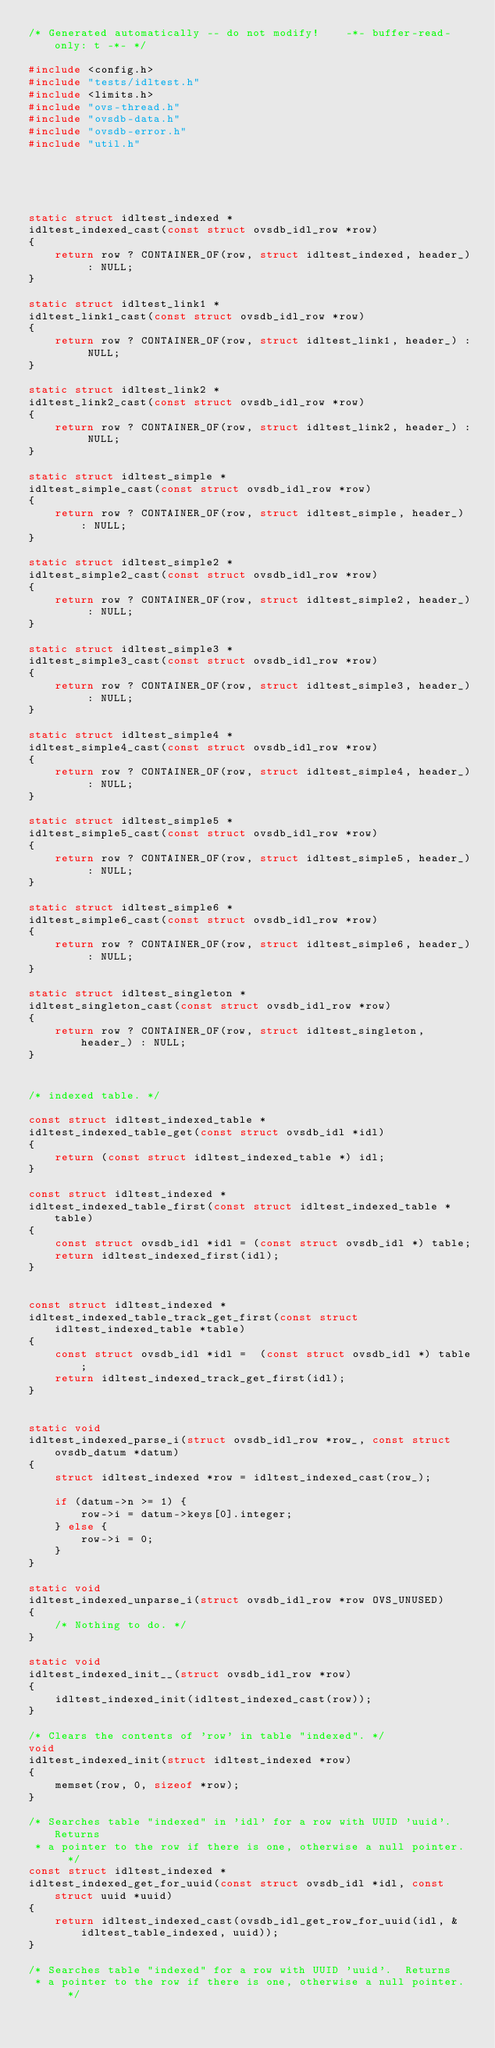<code> <loc_0><loc_0><loc_500><loc_500><_C_>/* Generated automatically -- do not modify!    -*- buffer-read-only: t -*- */

#include <config.h>
#include "tests/idltest.h"
#include <limits.h>
#include "ovs-thread.h"
#include "ovsdb-data.h"
#include "ovsdb-error.h"
#include "util.h"





static struct idltest_indexed *
idltest_indexed_cast(const struct ovsdb_idl_row *row)
{
    return row ? CONTAINER_OF(row, struct idltest_indexed, header_) : NULL;
}

static struct idltest_link1 *
idltest_link1_cast(const struct ovsdb_idl_row *row)
{
    return row ? CONTAINER_OF(row, struct idltest_link1, header_) : NULL;
}

static struct idltest_link2 *
idltest_link2_cast(const struct ovsdb_idl_row *row)
{
    return row ? CONTAINER_OF(row, struct idltest_link2, header_) : NULL;
}

static struct idltest_simple *
idltest_simple_cast(const struct ovsdb_idl_row *row)
{
    return row ? CONTAINER_OF(row, struct idltest_simple, header_) : NULL;
}

static struct idltest_simple2 *
idltest_simple2_cast(const struct ovsdb_idl_row *row)
{
    return row ? CONTAINER_OF(row, struct idltest_simple2, header_) : NULL;
}

static struct idltest_simple3 *
idltest_simple3_cast(const struct ovsdb_idl_row *row)
{
    return row ? CONTAINER_OF(row, struct idltest_simple3, header_) : NULL;
}

static struct idltest_simple4 *
idltest_simple4_cast(const struct ovsdb_idl_row *row)
{
    return row ? CONTAINER_OF(row, struct idltest_simple4, header_) : NULL;
}

static struct idltest_simple5 *
idltest_simple5_cast(const struct ovsdb_idl_row *row)
{
    return row ? CONTAINER_OF(row, struct idltest_simple5, header_) : NULL;
}

static struct idltest_simple6 *
idltest_simple6_cast(const struct ovsdb_idl_row *row)
{
    return row ? CONTAINER_OF(row, struct idltest_simple6, header_) : NULL;
}

static struct idltest_singleton *
idltest_singleton_cast(const struct ovsdb_idl_row *row)
{
    return row ? CONTAINER_OF(row, struct idltest_singleton, header_) : NULL;
}

/* indexed table. */

const struct idltest_indexed_table *
idltest_indexed_table_get(const struct ovsdb_idl *idl)
{
    return (const struct idltest_indexed_table *) idl;
}

const struct idltest_indexed *
idltest_indexed_table_first(const struct idltest_indexed_table *table)
{
    const struct ovsdb_idl *idl = (const struct ovsdb_idl *) table;
    return idltest_indexed_first(idl);
}


const struct idltest_indexed *
idltest_indexed_table_track_get_first(const struct idltest_indexed_table *table)
{
    const struct ovsdb_idl *idl =  (const struct ovsdb_idl *) table;
    return idltest_indexed_track_get_first(idl);
}


static void
idltest_indexed_parse_i(struct ovsdb_idl_row *row_, const struct ovsdb_datum *datum)
{
    struct idltest_indexed *row = idltest_indexed_cast(row_);

    if (datum->n >= 1) {
        row->i = datum->keys[0].integer;
    } else {
        row->i = 0;
    }
}

static void
idltest_indexed_unparse_i(struct ovsdb_idl_row *row OVS_UNUSED)
{
    /* Nothing to do. */
}

static void
idltest_indexed_init__(struct ovsdb_idl_row *row)
{
    idltest_indexed_init(idltest_indexed_cast(row));
}

/* Clears the contents of 'row' in table "indexed". */
void
idltest_indexed_init(struct idltest_indexed *row)
{
    memset(row, 0, sizeof *row); 
}

/* Searches table "indexed" in 'idl' for a row with UUID 'uuid'.  Returns
 * a pointer to the row if there is one, otherwise a null pointer.  */
const struct idltest_indexed *
idltest_indexed_get_for_uuid(const struct ovsdb_idl *idl, const struct uuid *uuid)
{
    return idltest_indexed_cast(ovsdb_idl_get_row_for_uuid(idl, &idltest_table_indexed, uuid));
}

/* Searches table "indexed" for a row with UUID 'uuid'.  Returns
 * a pointer to the row if there is one, otherwise a null pointer.  */</code> 